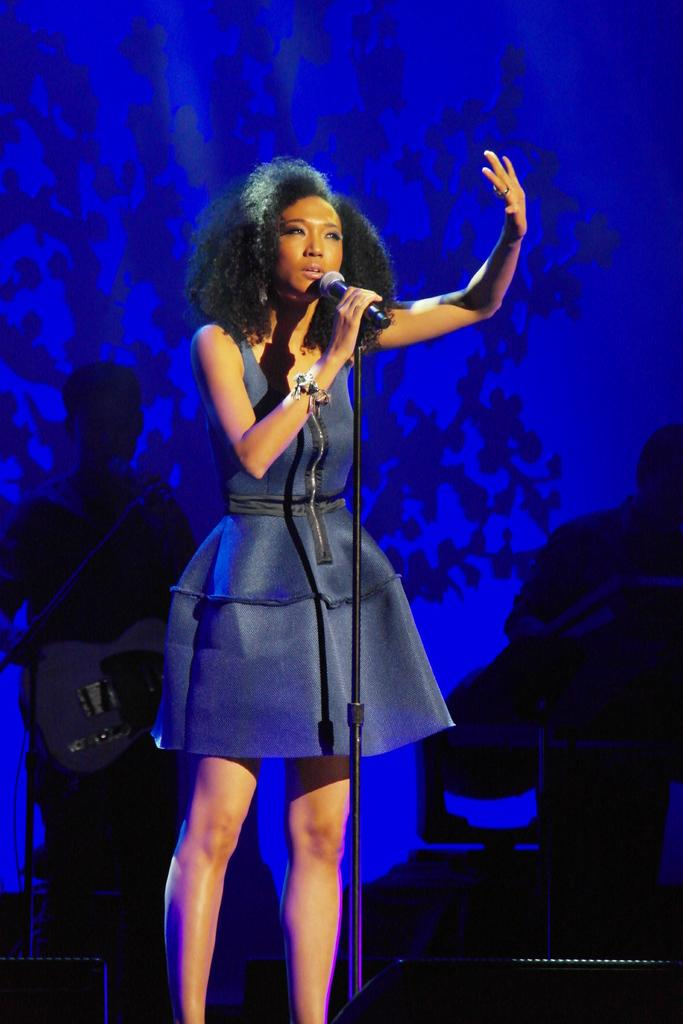Who is the main subject in the image? There is a woman in the image. What is the woman holding in the image? The woman is holding a microphone. Where is the woman positioned in the image? The woman is standing in the center of the image. Can you describe the people behind her in the image? There are other people behind her in the image. What color is the background in the image? The background is blue. How would you describe the lighting in the image? The overall lighting is dark. What type of net is being used to catch the current in the image? There is no net or current present in the image. 